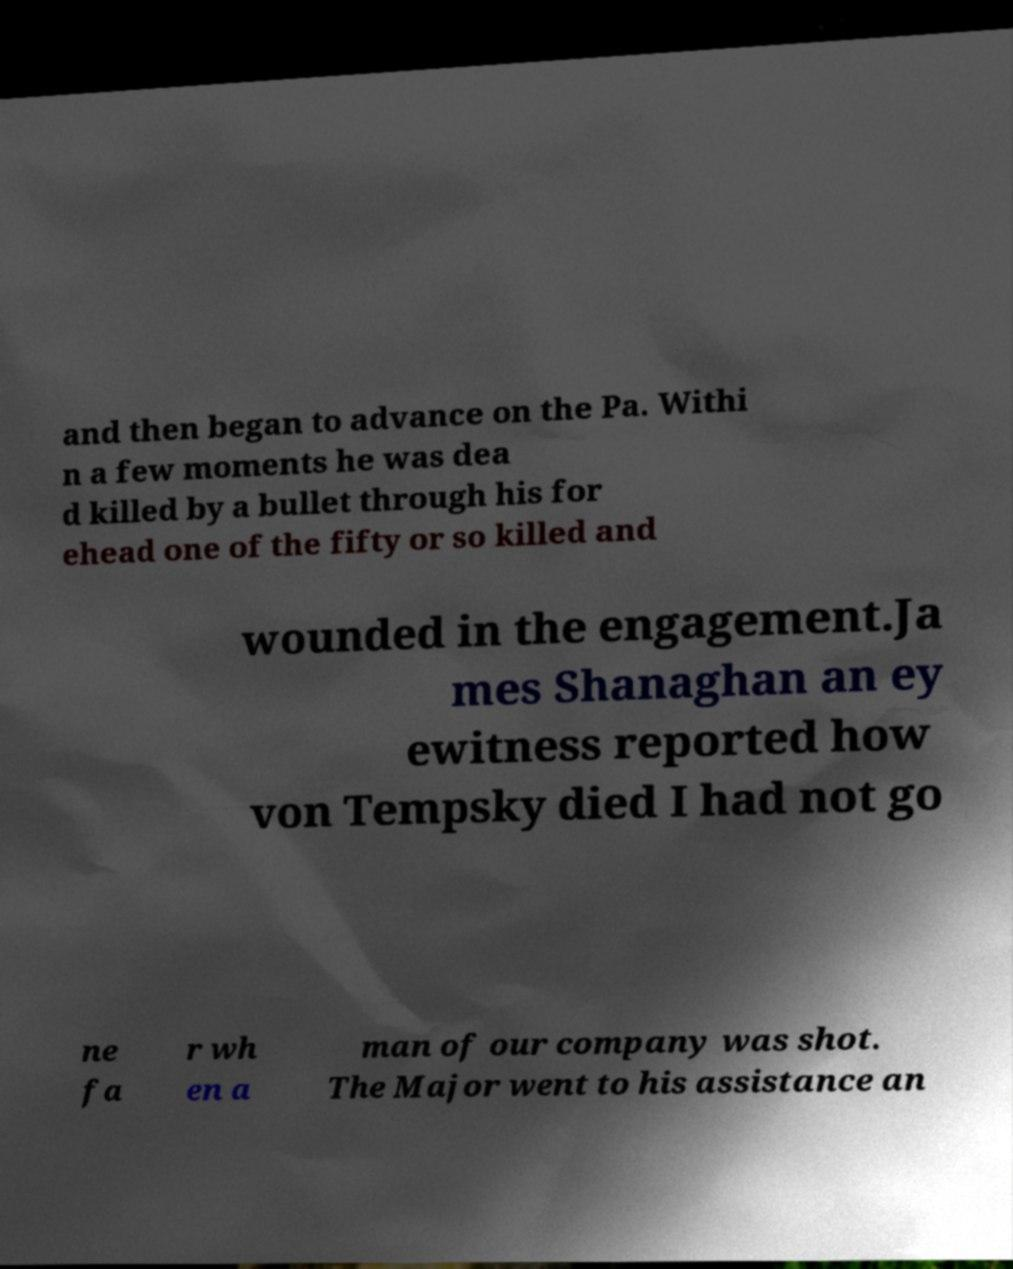Can you read and provide the text displayed in the image?This photo seems to have some interesting text. Can you extract and type it out for me? and then began to advance on the Pa. Withi n a few moments he was dea d killed by a bullet through his for ehead one of the fifty or so killed and wounded in the engagement.Ja mes Shanaghan an ey ewitness reported how von Tempsky died I had not go ne fa r wh en a man of our company was shot. The Major went to his assistance an 